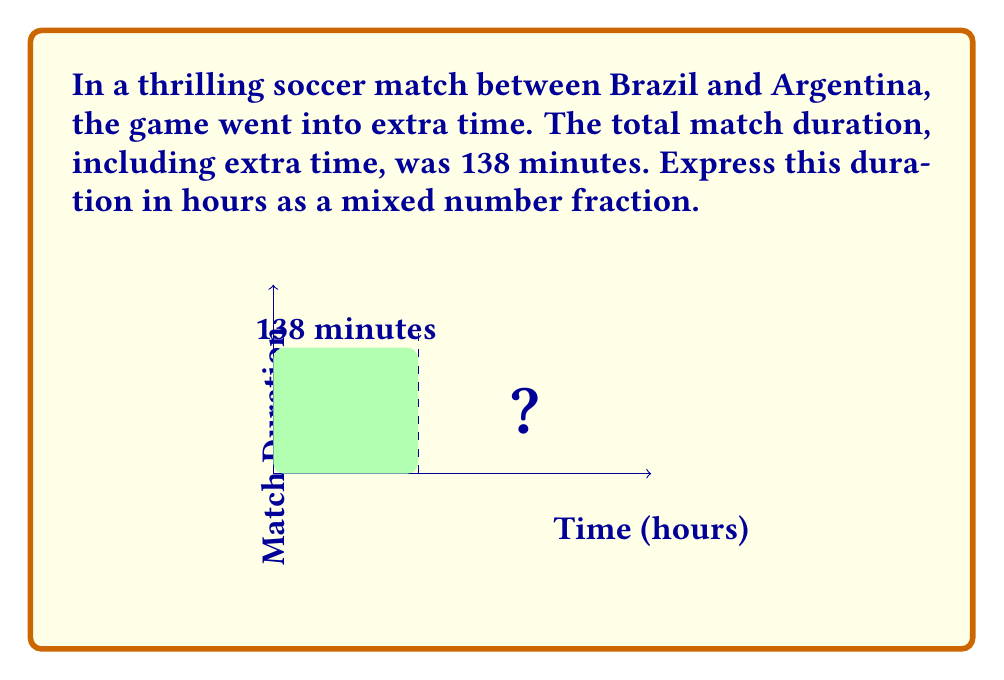Can you solve this math problem? Let's approach this step-by-step:

1) First, we need to convert 138 minutes to hours. We know that 1 hour = 60 minutes.

2) To convert minutes to hours, we divide the number of minutes by 60:

   $$ \frac{138 \text{ minutes}}{60 \text{ minutes/hour}} = 2.3 \text{ hours} $$

3) Now we need to express 2.3 hours as a mixed number fraction. The whole number part is 2.

4) For the fractional part, we subtract 2 from 2.3:

   $$ 2.3 - 2 = 0.3 $$

5) To convert 0.3 to a fraction, we can write it as:

   $$ 0.3 = \frac{3}{10} $$

6) Therefore, 2.3 hours as a mixed number fraction is:

   $$ 2\frac{3}{10} \text{ hours} $$

This means the match lasted 2 whole hours plus 3/10 of an hour.
Answer: $2\frac{3}{10}$ hours 